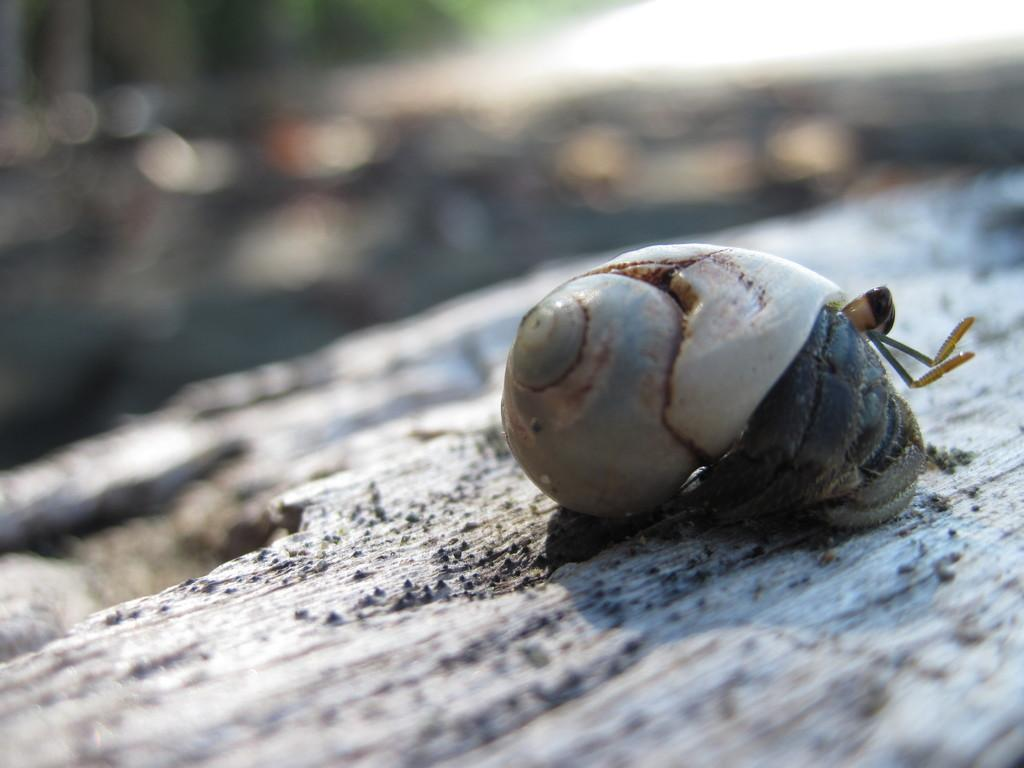What type of animal is in the image? There is a snail in the image. Where is the snail located? The snail is on an object that appears to be the ground. Can you describe the background of the image? The background of the image is blurry. What type of insurance does the snail have in the image? There is no information about insurance in the image, as it features a snail on the ground with a blurry background. 